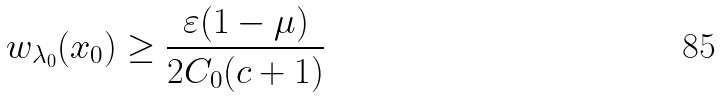<formula> <loc_0><loc_0><loc_500><loc_500>w _ { \lambda _ { 0 } } ( x _ { 0 } ) \geq \frac { \varepsilon ( 1 - \mu ) } { 2 C _ { 0 } ( c + 1 ) }</formula> 